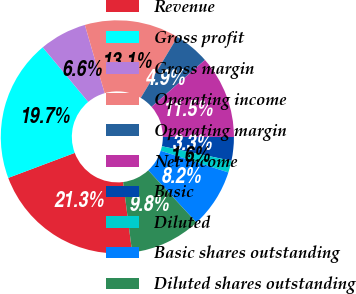Convert chart. <chart><loc_0><loc_0><loc_500><loc_500><pie_chart><fcel>Revenue<fcel>Gross profit<fcel>Gross margin<fcel>Operating income<fcel>Operating margin<fcel>Net income<fcel>Basic<fcel>Diluted<fcel>Basic shares outstanding<fcel>Diluted shares outstanding<nl><fcel>21.31%<fcel>19.67%<fcel>6.56%<fcel>13.11%<fcel>4.92%<fcel>11.48%<fcel>3.28%<fcel>1.64%<fcel>8.2%<fcel>9.84%<nl></chart> 